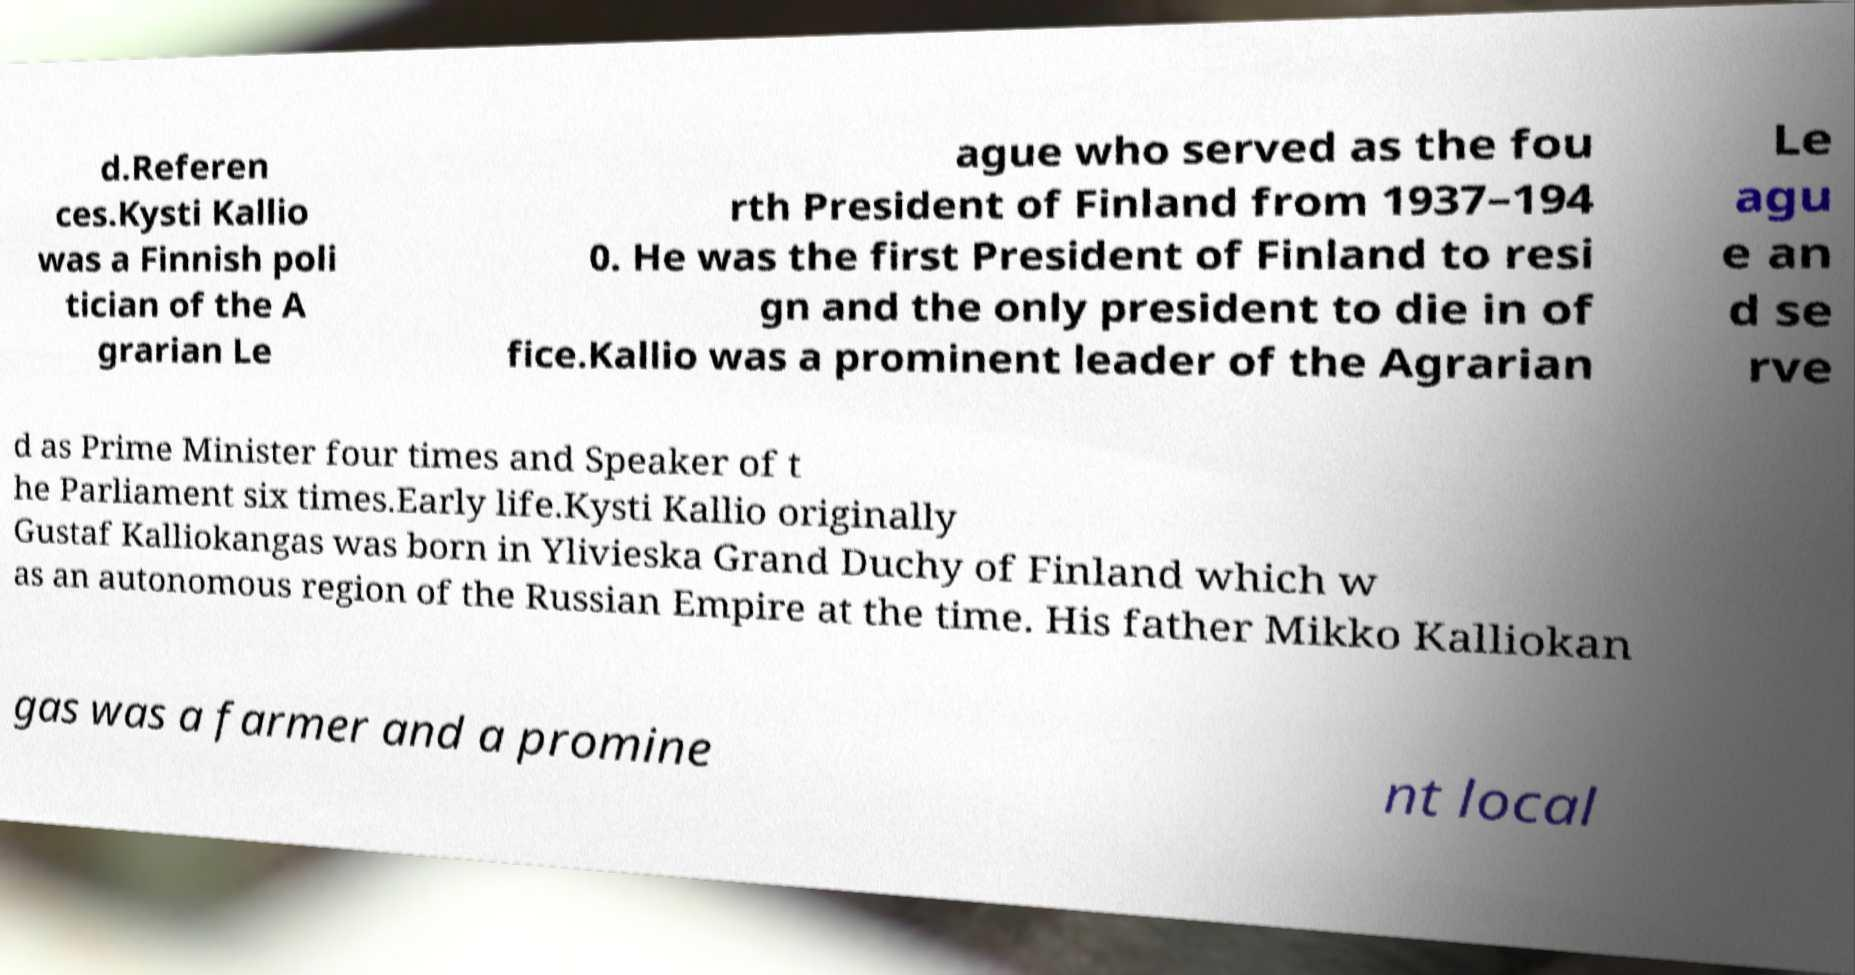For documentation purposes, I need the text within this image transcribed. Could you provide that? d.Referen ces.Kysti Kallio was a Finnish poli tician of the A grarian Le ague who served as the fou rth President of Finland from 1937–194 0. He was the first President of Finland to resi gn and the only president to die in of fice.Kallio was a prominent leader of the Agrarian Le agu e an d se rve d as Prime Minister four times and Speaker of t he Parliament six times.Early life.Kysti Kallio originally Gustaf Kalliokangas was born in Ylivieska Grand Duchy of Finland which w as an autonomous region of the Russian Empire at the time. His father Mikko Kalliokan gas was a farmer and a promine nt local 